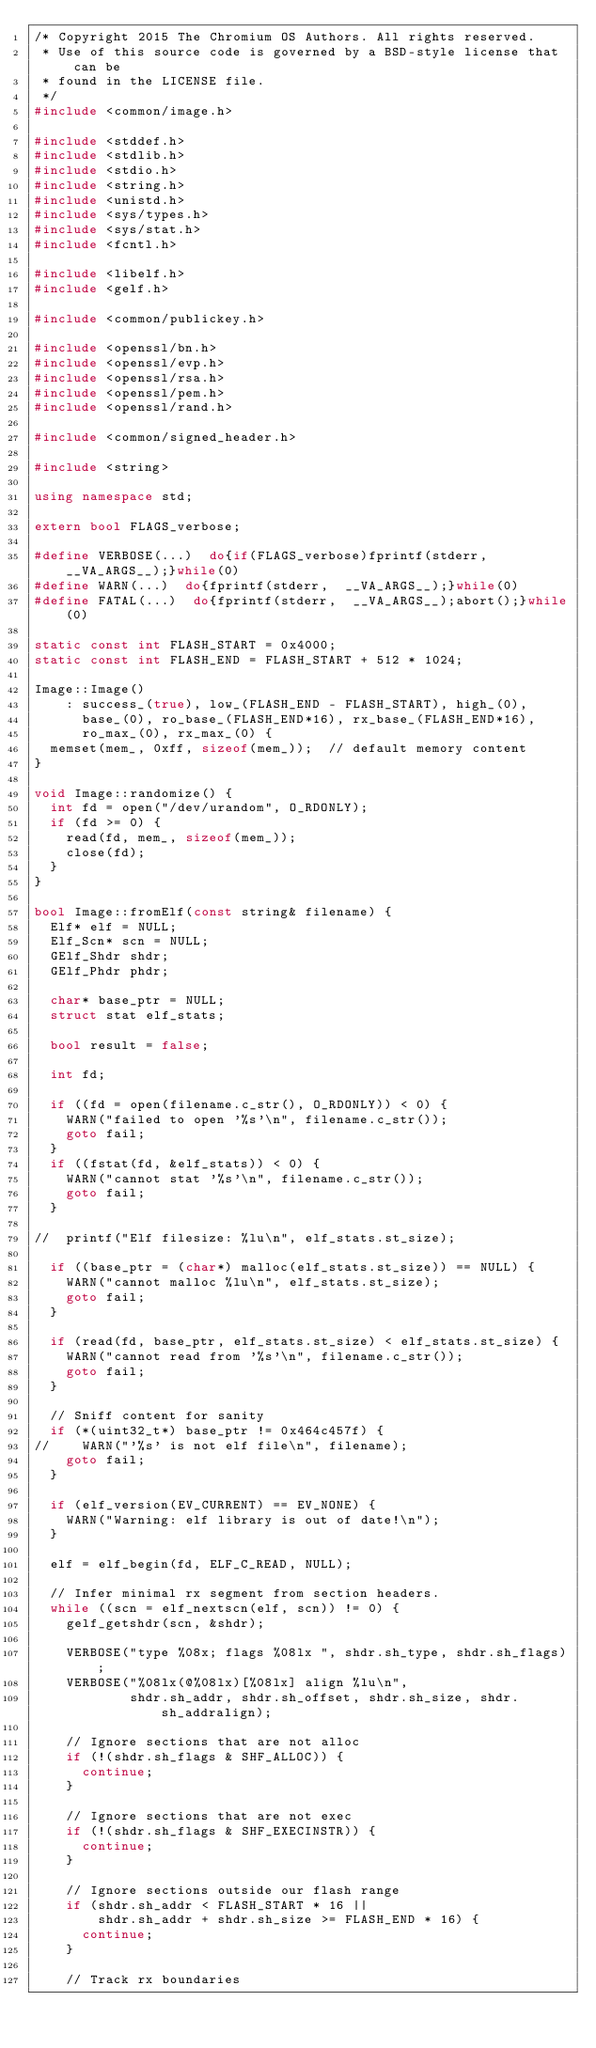Convert code to text. <code><loc_0><loc_0><loc_500><loc_500><_C++_>/* Copyright 2015 The Chromium OS Authors. All rights reserved.
 * Use of this source code is governed by a BSD-style license that can be
 * found in the LICENSE file.
 */
#include <common/image.h>

#include <stddef.h>
#include <stdlib.h>
#include <stdio.h>
#include <string.h>
#include <unistd.h>
#include <sys/types.h>
#include <sys/stat.h>
#include <fcntl.h>

#include <libelf.h>
#include <gelf.h>

#include <common/publickey.h>

#include <openssl/bn.h>
#include <openssl/evp.h>
#include <openssl/rsa.h>
#include <openssl/pem.h>
#include <openssl/rand.h>

#include <common/signed_header.h>

#include <string>

using namespace std;

extern bool FLAGS_verbose;

#define VERBOSE(...)  do{if(FLAGS_verbose)fprintf(stderr,  __VA_ARGS__);}while(0)
#define WARN(...)  do{fprintf(stderr,  __VA_ARGS__);}while(0)
#define FATAL(...)  do{fprintf(stderr,  __VA_ARGS__);abort();}while(0)

static const int FLASH_START = 0x4000;
static const int FLASH_END = FLASH_START + 512 * 1024;

Image::Image()
    : success_(true), low_(FLASH_END - FLASH_START), high_(0),
      base_(0), ro_base_(FLASH_END*16), rx_base_(FLASH_END*16),
      ro_max_(0), rx_max_(0) {
  memset(mem_, 0xff, sizeof(mem_));  // default memory content
}

void Image::randomize() {
  int fd = open("/dev/urandom", O_RDONLY);
  if (fd >= 0) {
    read(fd, mem_, sizeof(mem_));
    close(fd);
  }
}

bool Image::fromElf(const string& filename) {
  Elf* elf = NULL;
  Elf_Scn* scn = NULL;
  GElf_Shdr shdr;
  GElf_Phdr phdr;

  char* base_ptr = NULL;
  struct stat elf_stats;

  bool result = false;

  int fd;

  if ((fd = open(filename.c_str(), O_RDONLY)) < 0) {
    WARN("failed to open '%s'\n", filename.c_str());
    goto fail;
  }
  if ((fstat(fd, &elf_stats)) < 0) {
    WARN("cannot stat '%s'\n", filename.c_str());
    goto fail;
  }

//  printf("Elf filesize: %lu\n", elf_stats.st_size);

  if ((base_ptr = (char*) malloc(elf_stats.st_size)) == NULL) {
    WARN("cannot malloc %lu\n", elf_stats.st_size);
    goto fail;
  }

  if (read(fd, base_ptr, elf_stats.st_size) < elf_stats.st_size) {
    WARN("cannot read from '%s'\n", filename.c_str());
    goto fail;
  }

  // Sniff content for sanity
  if (*(uint32_t*) base_ptr != 0x464c457f) {
//    WARN("'%s' is not elf file\n", filename);
    goto fail;
  }

  if (elf_version(EV_CURRENT) == EV_NONE) {
    WARN("Warning: elf library is out of date!\n");
  }

  elf = elf_begin(fd, ELF_C_READ, NULL);

  // Infer minimal rx segment from section headers.
  while ((scn = elf_nextscn(elf, scn)) != 0) {
    gelf_getshdr(scn, &shdr);

    VERBOSE("type %08x; flags %08lx ", shdr.sh_type, shdr.sh_flags);
    VERBOSE("%08lx(@%08lx)[%08lx] align %lu\n",
            shdr.sh_addr, shdr.sh_offset, shdr.sh_size, shdr.sh_addralign);

    // Ignore sections that are not alloc
    if (!(shdr.sh_flags & SHF_ALLOC)) {
      continue;
    }

    // Ignore sections that are not exec
    if (!(shdr.sh_flags & SHF_EXECINSTR)) {
      continue;
    }

    // Ignore sections outside our flash range
    if (shdr.sh_addr < FLASH_START * 16 ||
        shdr.sh_addr + shdr.sh_size >= FLASH_END * 16) {
      continue;
    }

    // Track rx boundaries</code> 